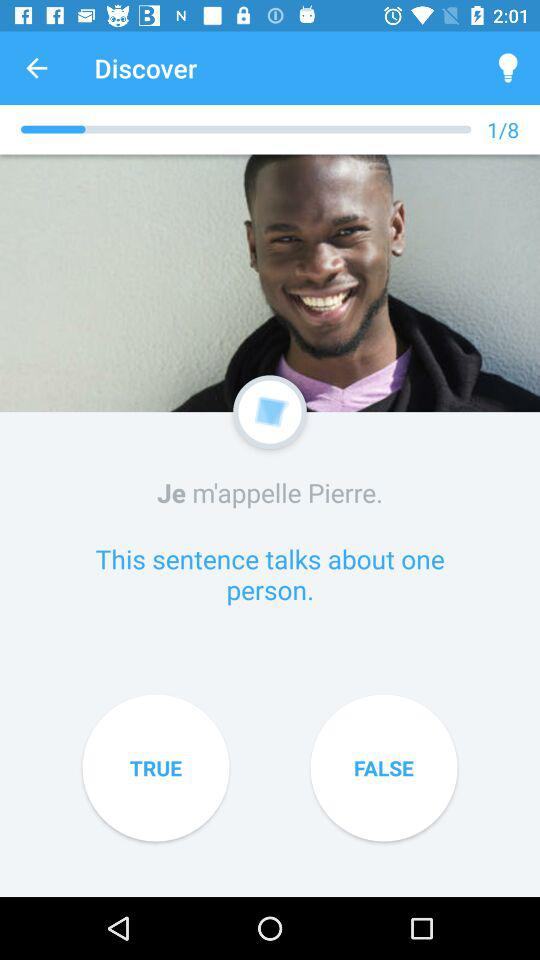What is the song name?
When the provided information is insufficient, respond with <no answer>. <no answer> 